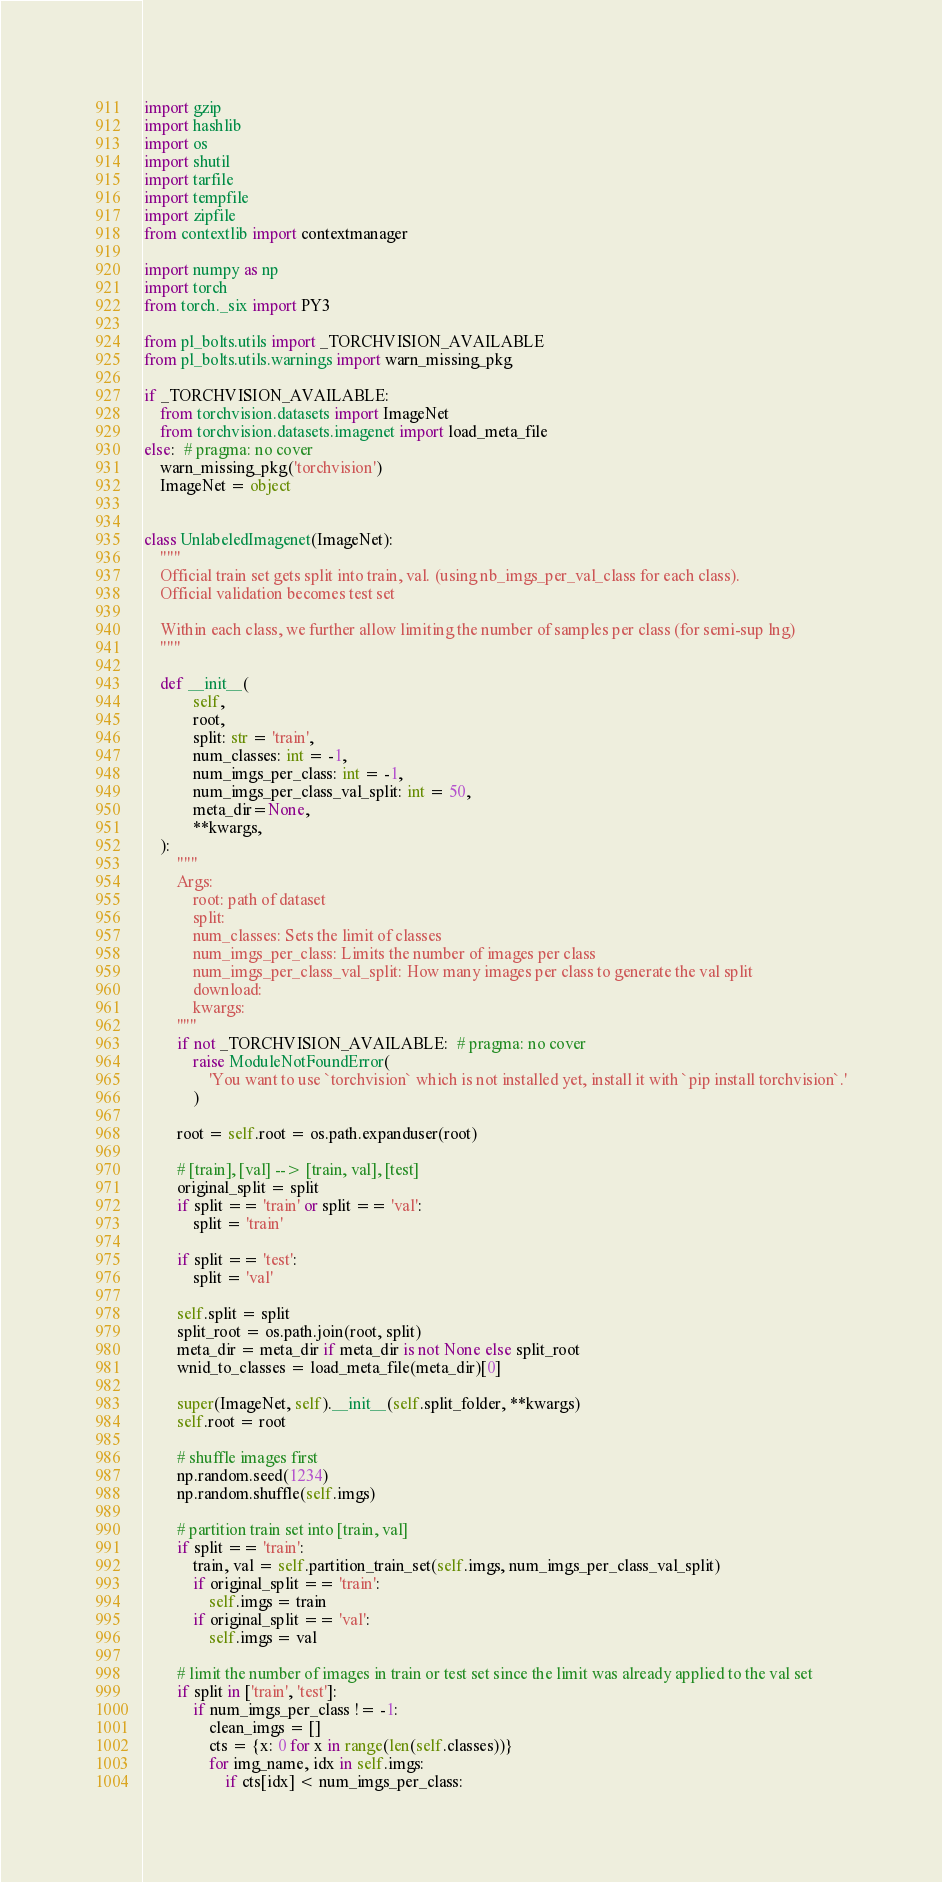<code> <loc_0><loc_0><loc_500><loc_500><_Python_>import gzip
import hashlib
import os
import shutil
import tarfile
import tempfile
import zipfile
from contextlib import contextmanager

import numpy as np
import torch
from torch._six import PY3

from pl_bolts.utils import _TORCHVISION_AVAILABLE
from pl_bolts.utils.warnings import warn_missing_pkg

if _TORCHVISION_AVAILABLE:
    from torchvision.datasets import ImageNet
    from torchvision.datasets.imagenet import load_meta_file
else:  # pragma: no cover
    warn_missing_pkg('torchvision')
    ImageNet = object


class UnlabeledImagenet(ImageNet):
    """
    Official train set gets split into train, val. (using nb_imgs_per_val_class for each class).
    Official validation becomes test set

    Within each class, we further allow limiting the number of samples per class (for semi-sup lng)
    """

    def __init__(
            self,
            root,
            split: str = 'train',
            num_classes: int = -1,
            num_imgs_per_class: int = -1,
            num_imgs_per_class_val_split: int = 50,
            meta_dir=None,
            **kwargs,
    ):
        """
        Args:
            root: path of dataset
            split:
            num_classes: Sets the limit of classes
            num_imgs_per_class: Limits the number of images per class
            num_imgs_per_class_val_split: How many images per class to generate the val split
            download:
            kwargs:
        """
        if not _TORCHVISION_AVAILABLE:  # pragma: no cover
            raise ModuleNotFoundError(
                'You want to use `torchvision` which is not installed yet, install it with `pip install torchvision`.'
            )

        root = self.root = os.path.expanduser(root)

        # [train], [val] --> [train, val], [test]
        original_split = split
        if split == 'train' or split == 'val':
            split = 'train'

        if split == 'test':
            split = 'val'

        self.split = split
        split_root = os.path.join(root, split)
        meta_dir = meta_dir if meta_dir is not None else split_root
        wnid_to_classes = load_meta_file(meta_dir)[0]

        super(ImageNet, self).__init__(self.split_folder, **kwargs)
        self.root = root

        # shuffle images first
        np.random.seed(1234)
        np.random.shuffle(self.imgs)

        # partition train set into [train, val]
        if split == 'train':
            train, val = self.partition_train_set(self.imgs, num_imgs_per_class_val_split)
            if original_split == 'train':
                self.imgs = train
            if original_split == 'val':
                self.imgs = val

        # limit the number of images in train or test set since the limit was already applied to the val set
        if split in ['train', 'test']:
            if num_imgs_per_class != -1:
                clean_imgs = []
                cts = {x: 0 for x in range(len(self.classes))}
                for img_name, idx in self.imgs:
                    if cts[idx] < num_imgs_per_class:</code> 